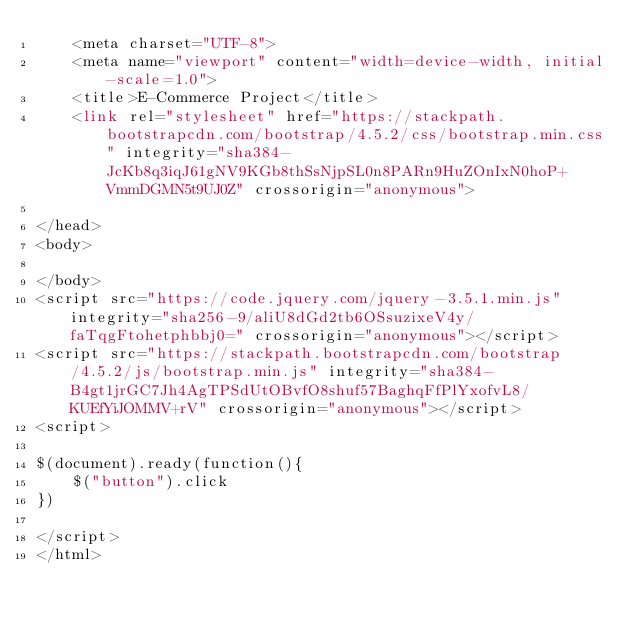<code> <loc_0><loc_0><loc_500><loc_500><_PHP_>    <meta charset="UTF-8">
    <meta name="viewport" content="width=device-width, initial-scale=1.0">
    <title>E-Commerce Project</title>
    <link rel="stylesheet" href="https://stackpath.bootstrapcdn.com/bootstrap/4.5.2/css/bootstrap.min.css" integrity="sha384-JcKb8q3iqJ61gNV9KGb8thSsNjpSL0n8PARn9HuZOnIxN0hoP+VmmDGMN5t9UJ0Z" crossorigin="anonymous">

</head>
<body>
    
</body>
<script src="https://code.jquery.com/jquery-3.5.1.min.js" integrity="sha256-9/aliU8dGd2tb6OSsuzixeV4y/faTqgFtohetphbbj0=" crossorigin="anonymous"></script>
<script src="https://stackpath.bootstrapcdn.com/bootstrap/4.5.2/js/bootstrap.min.js" integrity="sha384-B4gt1jrGC7Jh4AgTPSdUtOBvfO8shuf57BaghqFfPlYxofvL8/KUEfYiJOMMV+rV" crossorigin="anonymous"></script>
<script>   

$(document).ready(function(){
    $("button").click
})

</script>
</html></code> 